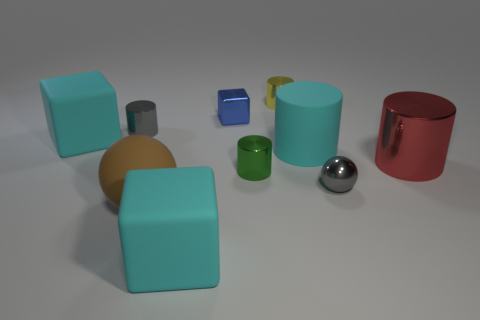Subtract all gray cylinders. How many cylinders are left? 4 Subtract all red cylinders. How many cylinders are left? 4 Subtract all brown cylinders. Subtract all red spheres. How many cylinders are left? 5 Subtract all blocks. How many objects are left? 7 Add 9 cyan matte cylinders. How many cyan matte cylinders exist? 10 Subtract 1 red cylinders. How many objects are left? 9 Subtract all small yellow rubber balls. Subtract all green metal cylinders. How many objects are left? 9 Add 1 gray balls. How many gray balls are left? 2 